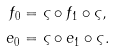Convert formula to latex. <formula><loc_0><loc_0><loc_500><loc_500>f _ { 0 } & = \varsigma \circ f _ { 1 } \circ \varsigma , \\ e _ { 0 } & = \varsigma \circ e _ { 1 } \circ \varsigma .</formula> 